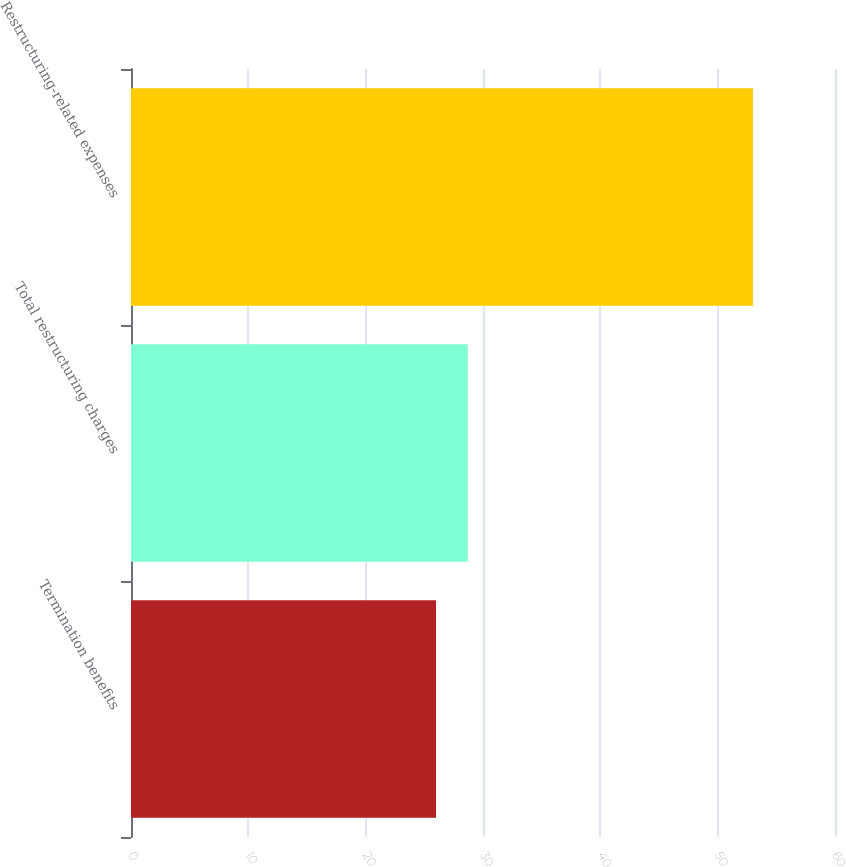Convert chart to OTSL. <chart><loc_0><loc_0><loc_500><loc_500><bar_chart><fcel>Termination benefits<fcel>Total restructuring charges<fcel>Restructuring-related expenses<nl><fcel>26<fcel>28.7<fcel>53<nl></chart> 